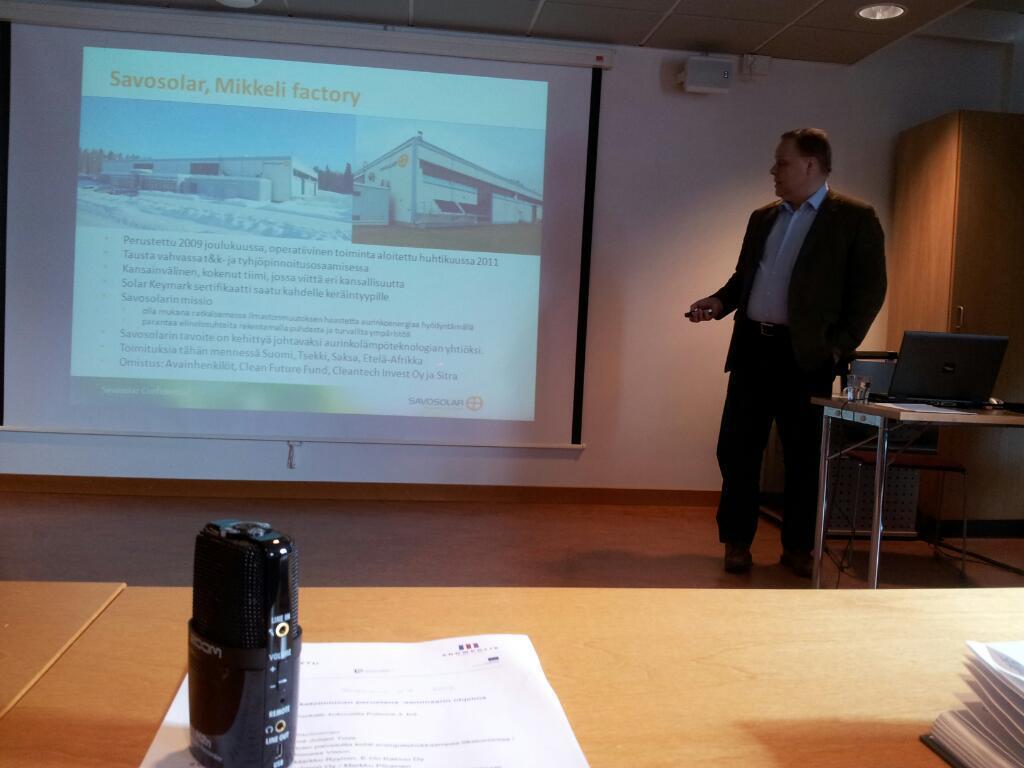Can you describe this image briefly? a person standing in front of a table on the table there are many items here we can see a screen on the wall 